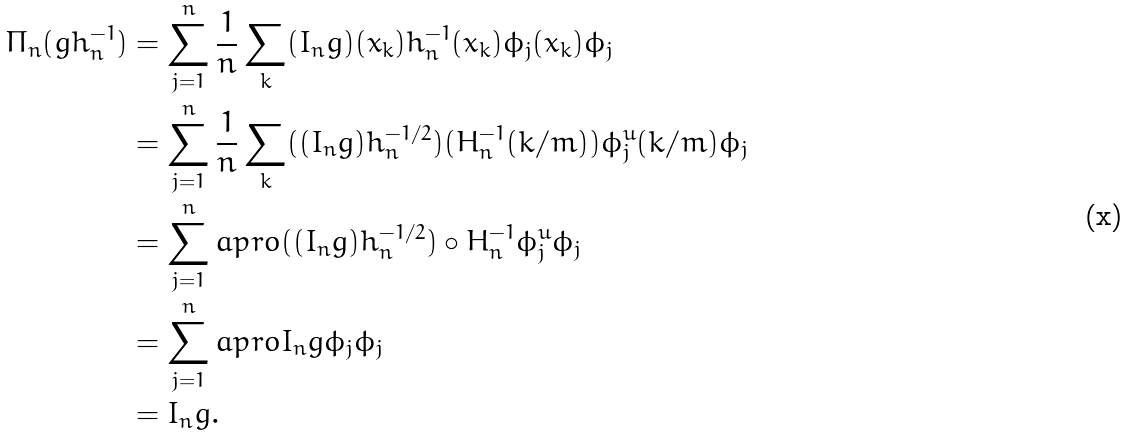Convert formula to latex. <formula><loc_0><loc_0><loc_500><loc_500>\Pi _ { n } ( g h _ { n } ^ { - 1 } ) & = \sum _ { j = 1 } ^ { n } \frac { 1 } { n } \sum _ { k } ( I _ { n } g ) ( x _ { k } ) h _ { n } ^ { - 1 } ( x _ { k } ) \phi _ { j } ( x _ { k } ) \phi _ { j } \\ & = \sum _ { j = 1 } ^ { n } \frac { 1 } { n } \sum _ { k } ( ( I _ { n } g ) h _ { n } ^ { - 1 / 2 } ) ( H _ { n } ^ { - 1 } ( k / m ) ) \phi _ { j } ^ { u } ( k / m ) \phi _ { j } \\ & = \sum _ { j = 1 } ^ { n } a p r o { ( ( I _ { n } g ) h _ { n } ^ { - 1 / 2 } ) \circ H _ { n } ^ { - 1 } } { \phi _ { j } ^ { u } } \phi _ { j } \\ & = \sum _ { j = 1 } ^ { n } a p r o { I _ { n } g } { \phi _ { j } } \phi _ { j } \\ & = I _ { n } g .</formula> 